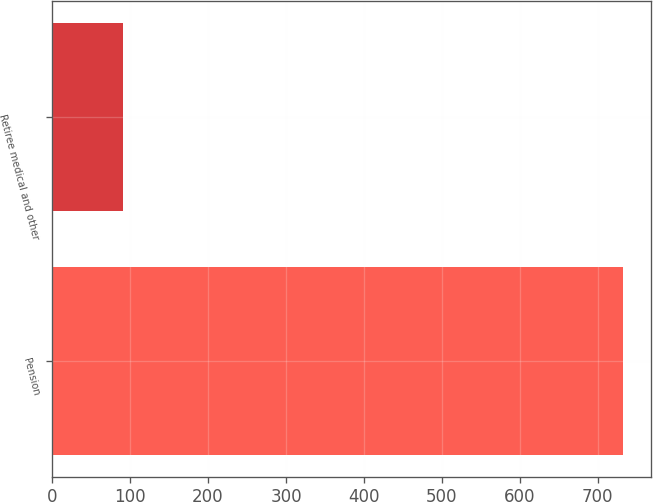<chart> <loc_0><loc_0><loc_500><loc_500><bar_chart><fcel>Pension<fcel>Retiree medical and other<nl><fcel>732<fcel>91<nl></chart> 